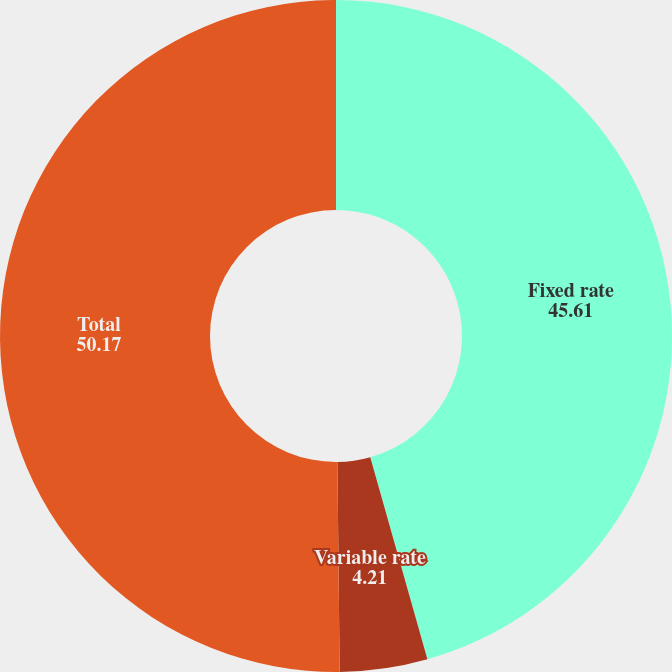Convert chart. <chart><loc_0><loc_0><loc_500><loc_500><pie_chart><fcel>Fixed rate<fcel>Variable rate<fcel>Total<nl><fcel>45.61%<fcel>4.21%<fcel>50.17%<nl></chart> 